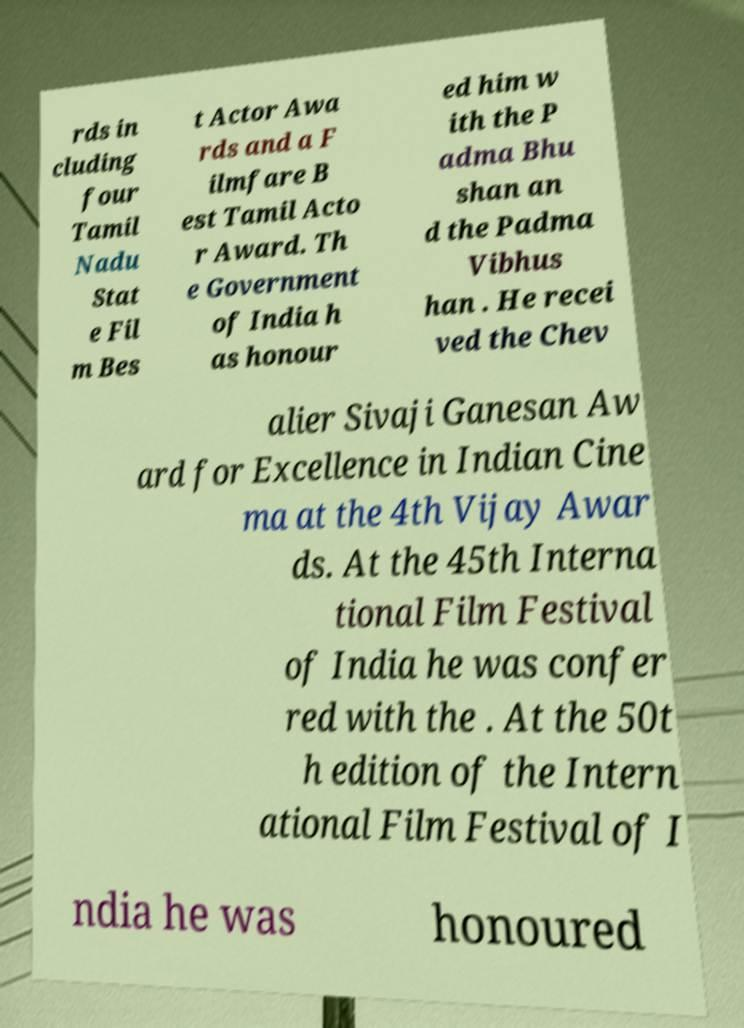Could you assist in decoding the text presented in this image and type it out clearly? rds in cluding four Tamil Nadu Stat e Fil m Bes t Actor Awa rds and a F ilmfare B est Tamil Acto r Award. Th e Government of India h as honour ed him w ith the P adma Bhu shan an d the Padma Vibhus han . He recei ved the Chev alier Sivaji Ganesan Aw ard for Excellence in Indian Cine ma at the 4th Vijay Awar ds. At the 45th Interna tional Film Festival of India he was confer red with the . At the 50t h edition of the Intern ational Film Festival of I ndia he was honoured 